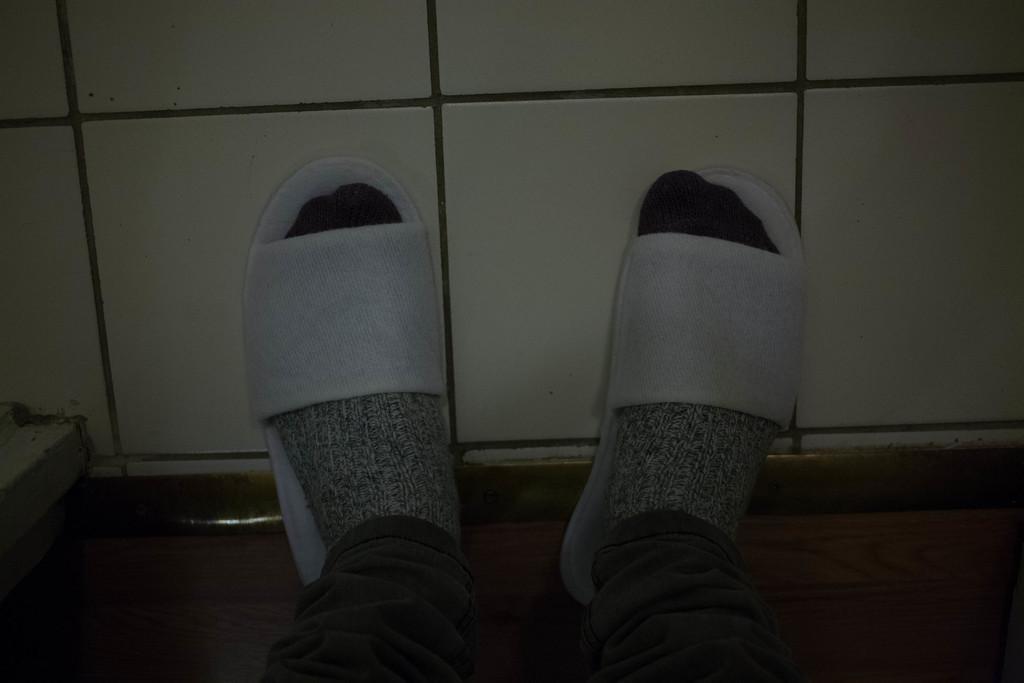Describe this image in one or two sentences. In this image I can see a person legs wearing white color slippers and socks. Background is in white color. 